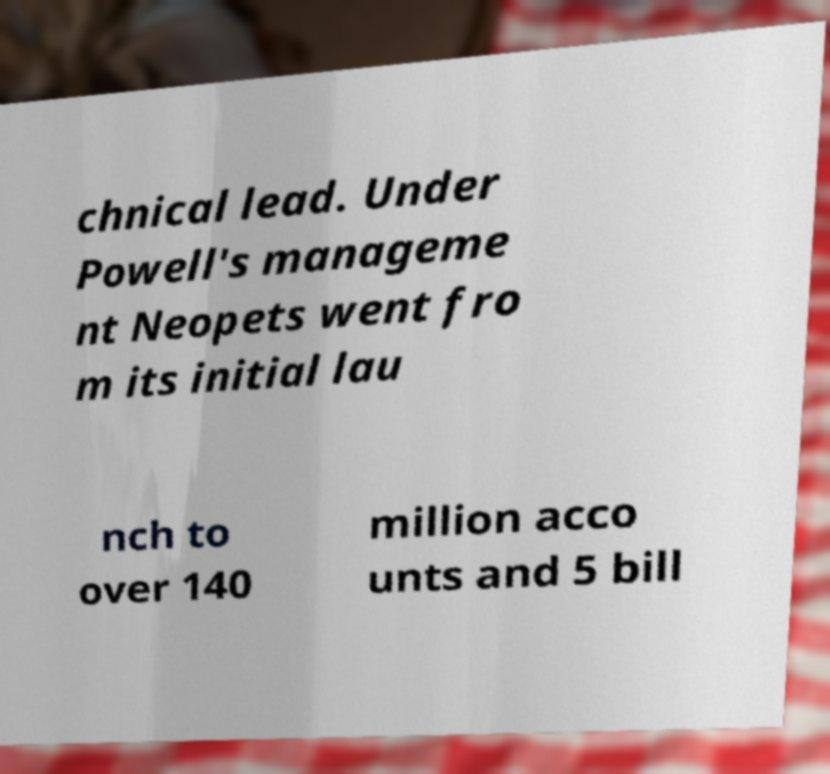Could you extract and type out the text from this image? chnical lead. Under Powell's manageme nt Neopets went fro m its initial lau nch to over 140 million acco unts and 5 bill 